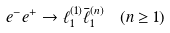Convert formula to latex. <formula><loc_0><loc_0><loc_500><loc_500>e ^ { - } e ^ { + } & \to \ell _ { 1 } ^ { ( 1 ) } \bar { \ell } _ { 1 } ^ { ( n ) } \quad ( n \geq 1 )</formula> 